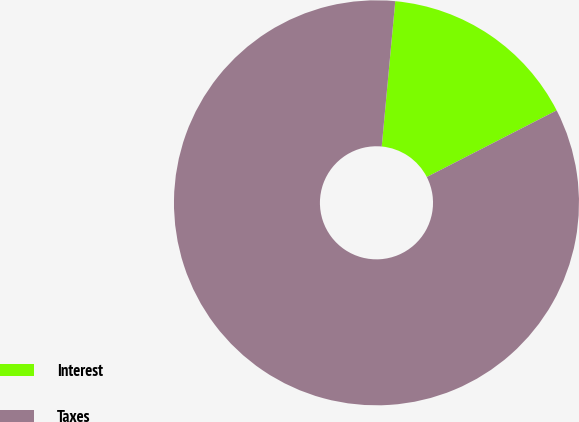Convert chart. <chart><loc_0><loc_0><loc_500><loc_500><pie_chart><fcel>Interest<fcel>Taxes<nl><fcel>15.98%<fcel>84.02%<nl></chart> 